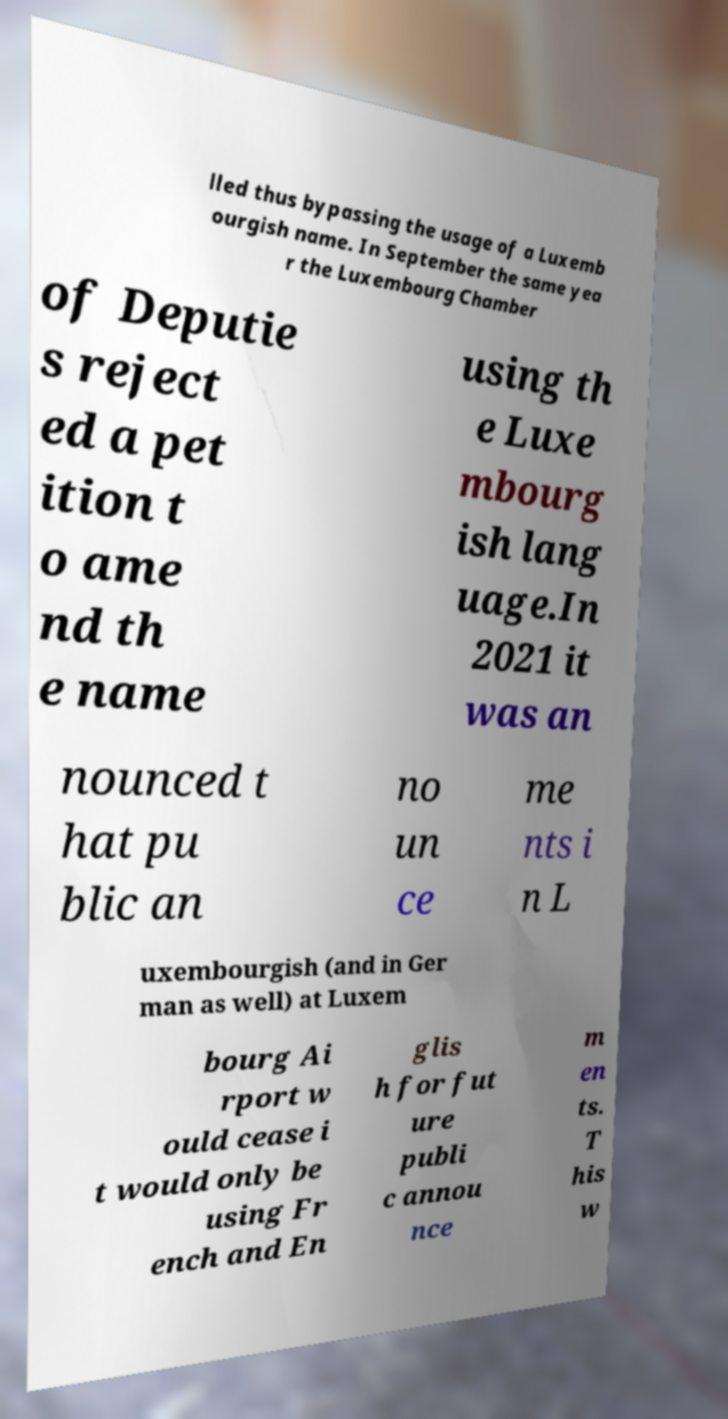Can you accurately transcribe the text from the provided image for me? lled thus bypassing the usage of a Luxemb ourgish name. In September the same yea r the Luxembourg Chamber of Deputie s reject ed a pet ition t o ame nd th e name using th e Luxe mbourg ish lang uage.In 2021 it was an nounced t hat pu blic an no un ce me nts i n L uxembourgish (and in Ger man as well) at Luxem bourg Ai rport w ould cease i t would only be using Fr ench and En glis h for fut ure publi c annou nce m en ts. T his w 